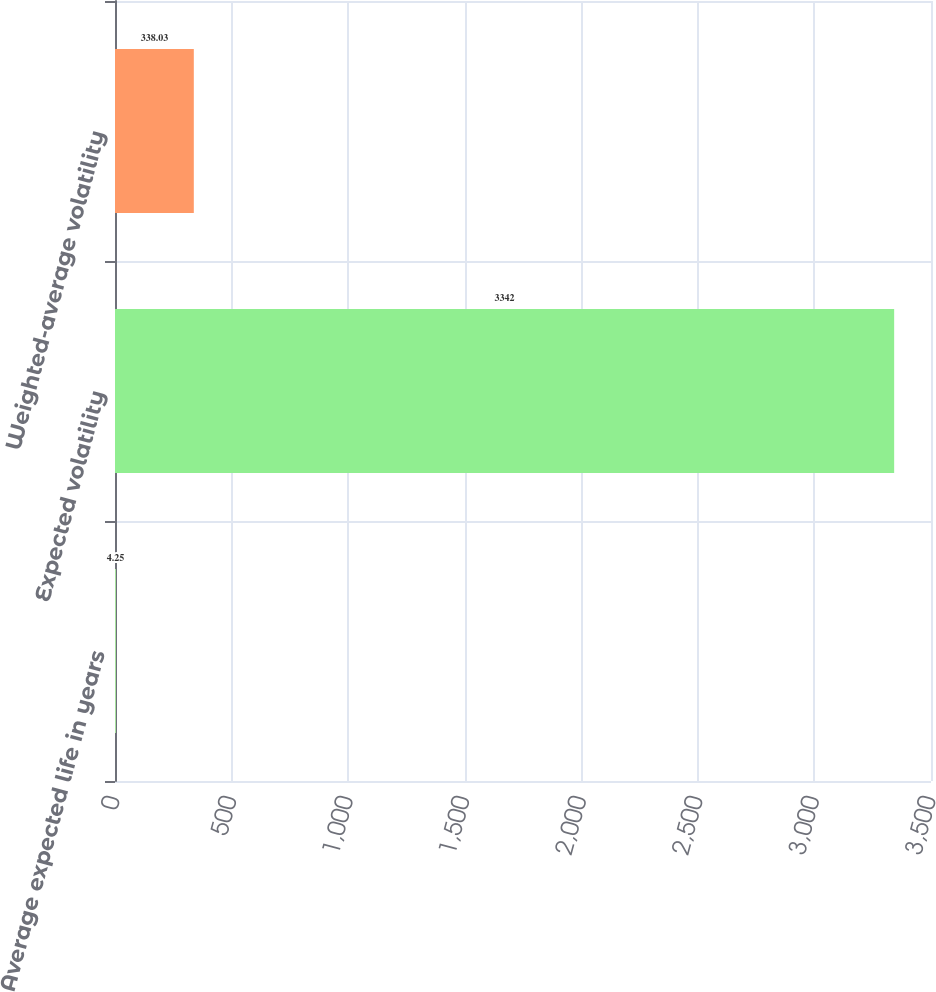Convert chart. <chart><loc_0><loc_0><loc_500><loc_500><bar_chart><fcel>Average expected life in years<fcel>Expected volatility<fcel>Weighted-average volatility<nl><fcel>4.25<fcel>3342<fcel>338.03<nl></chart> 